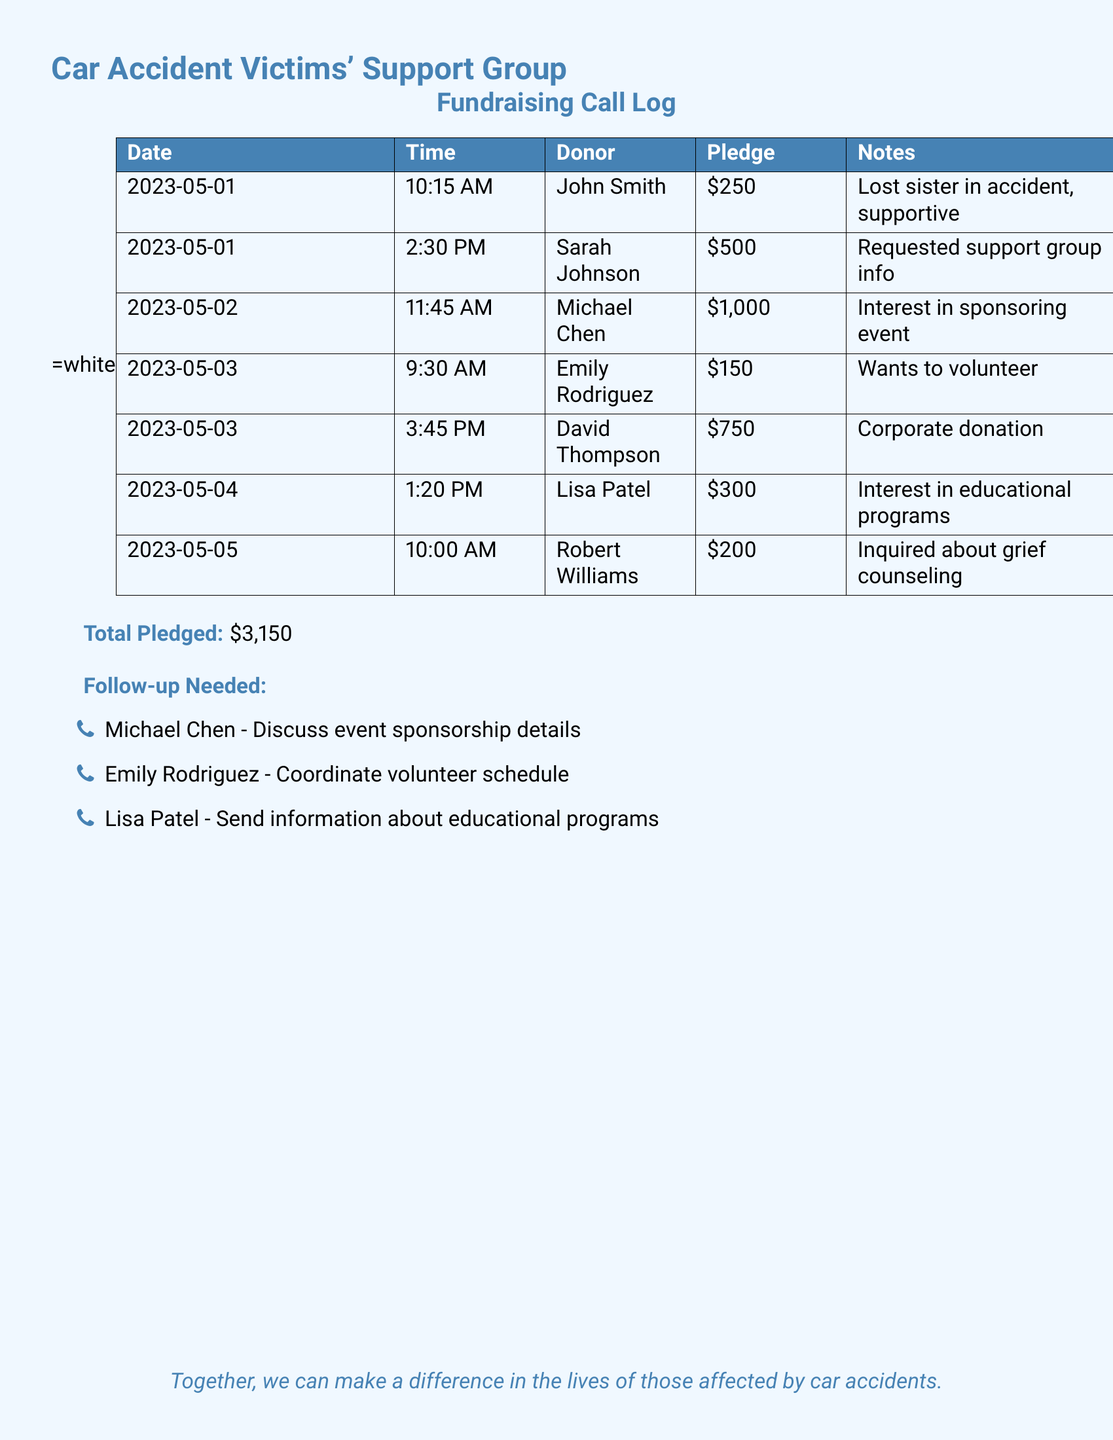What is the date of John Smith's pledge? The date of John Smith's pledge is recorded in the call log as May 1, 2023.
Answer: May 1, 2023 How much did Sarah Johnson pledge? Sarah Johnson's pledged amount is noted in the document as $500.
Answer: $500 Who expressed interest in sponsoring an event? Michael Chen is the individual who expressed interest in sponsoring an event according to the log.
Answer: Michael Chen What is the total amount pledged? The total amount pledged is calculated and stated clearly in the document as $3,150.
Answer: $3,150 Which donor requested support group information? The donor who requested support group information is Sarah Johnson, as noted in the document.
Answer: Sarah Johnson What kind of donation did David Thompson make? David Thompson made a corporate donation, as stated in the notes.
Answer: Corporate donation Which individual needs a follow-up about coordinating a volunteer schedule? Emily Rodriguez is the individual that requires a follow-up for coordinating a volunteer schedule.
Answer: Emily Rodriguez What is the time of Robert Williams' call? The time of Robert Williams' call is recorded as 10:00 AM on May 5, 2023.
Answer: 10:00 AM What type of volunteer opportunity did Emily Rodriguez express interest in? Emily Rodriguez expressed interest specifically in volunteering, as stated in her notes.
Answer: Volunteering 